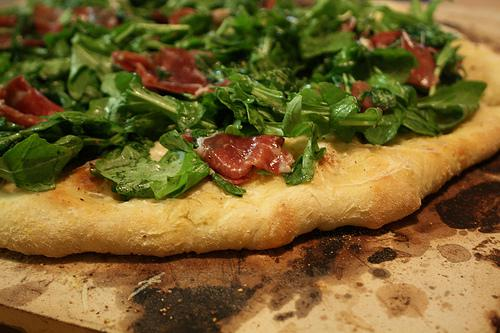Question: what is in the picture?
Choices:
A. Tacos.
B. Soup.
C. Pizza.
D. Ice cream.
Answer with the letter. Answer: C Question: why is there dark spots under the pizza?
Choices:
A. Burnt crust..
B. Charcoal residue.
C. Burnt cheese.
D. From the grease.
Answer with the letter. Answer: D Question: how is the pizza cut?
Choices:
A. In half.
B. It's not cut.
C. In quarters.
D. In slices.
Answer with the letter. Answer: B Question: how much of the pizza can you see?
Choices:
A. About half.
B. One slice.
C. The whole pizza.
D. Three-quarters of the pizza.
Answer with the letter. Answer: A Question: what is on the pizza?
Choices:
A. Cheese and pepperoni.
B. Lettuce and bacon.
C. Mushrooms.
D. Olives.
Answer with the letter. Answer: B Question: what color is the bacon?
Choices:
A. Brown.
B. Red.
C. White and red.
D. Brown and white.
Answer with the letter. Answer: B 